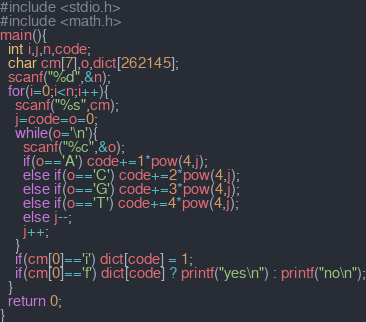<code> <loc_0><loc_0><loc_500><loc_500><_C_>#include <stdio.h>
#include <math.h>
main(){
  int i,j,n,code;
  char cm[7],o,dict[262145];
  scanf("%d",&n);
  for(i=0;i<n;i++){
    scanf("%s",cm);
    j=code=o=0;
    while(o='\n'){
      scanf("%c",&o);
      if(o=='A') code+=1*pow(4,j);
      else if(o=='C') code+=2*pow(4,j);
      else if(o=='G') code+=3*pow(4,j);
      else if(o=='T') code+=4*pow(4,j);
      else j--;
      j++;
    }
    if(cm[0]=='i') dict[code] = 1;
    if(cm[0]=='f') dict[code] ? printf("yes\n") : printf("no\n");
  }
  return 0;
}</code> 